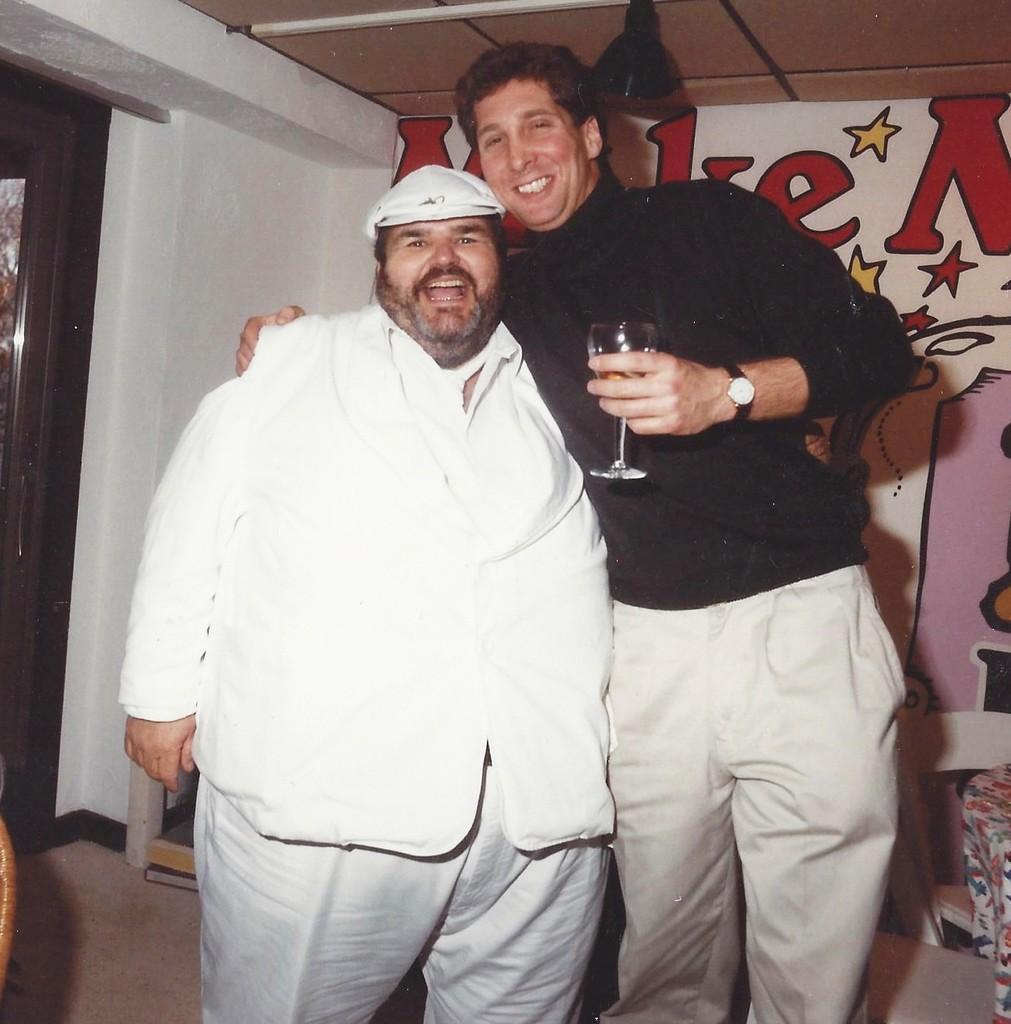Please provide a concise description of this image. the picture two men standing and a man holding a wine glass in his hand and we see a poster on the wall on their back. 